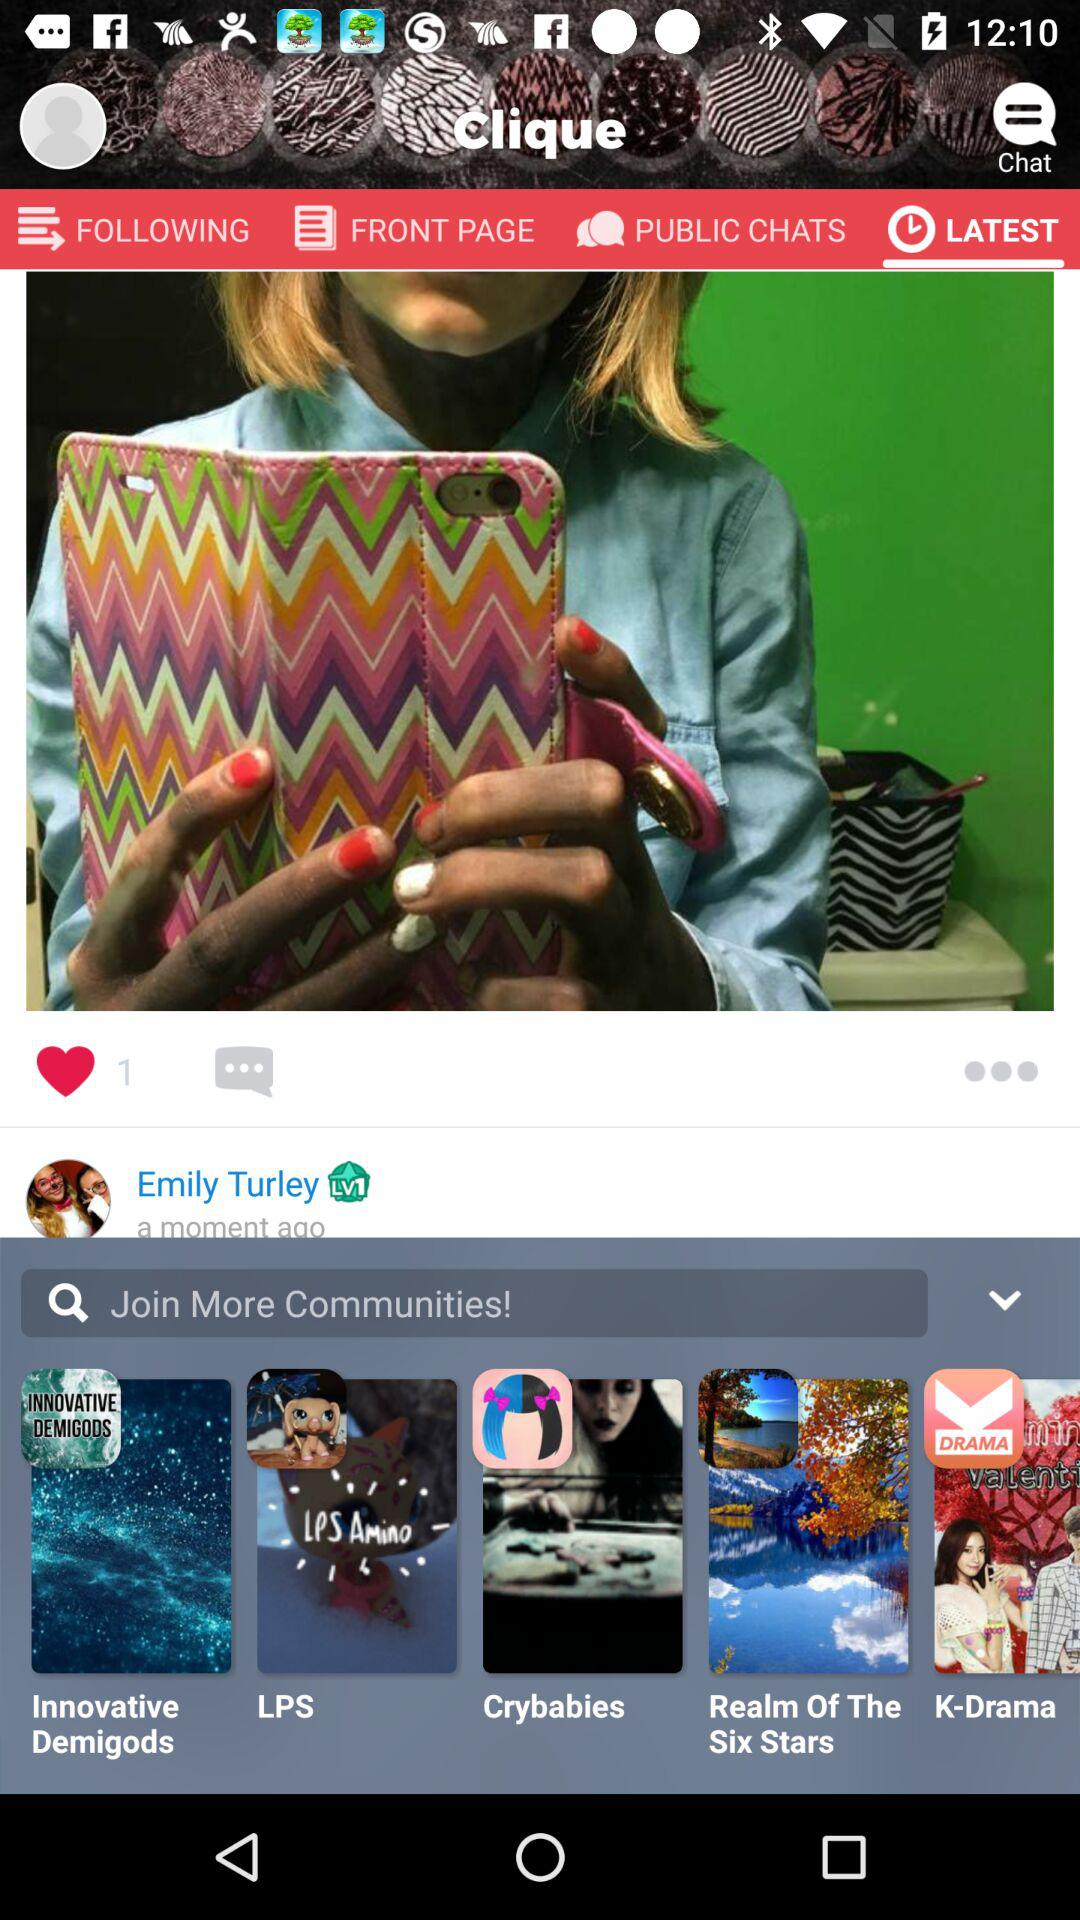Which tab has been selected? The selected tab is "LATEST". 